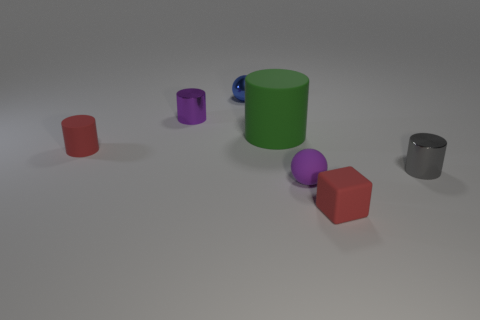Subtract all tiny red matte cylinders. How many cylinders are left? 3 Subtract all gray cylinders. How many cylinders are left? 3 Add 2 purple rubber cylinders. How many objects exist? 9 Subtract 1 cylinders. How many cylinders are left? 3 Subtract all yellow cylinders. Subtract all red cubes. How many cylinders are left? 4 Subtract all spheres. How many objects are left? 5 Add 1 red things. How many red things are left? 3 Add 7 matte blocks. How many matte blocks exist? 8 Subtract 0 green blocks. How many objects are left? 7 Subtract all tiny spheres. Subtract all gray balls. How many objects are left? 5 